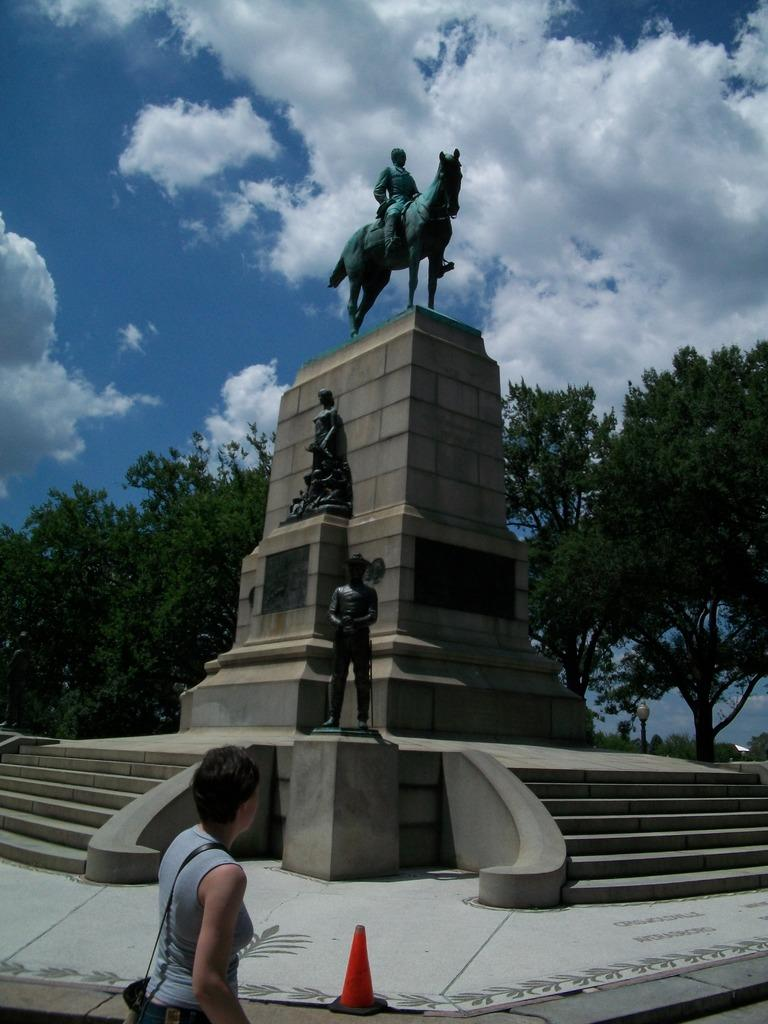What is the main subject in the image? There is a person standing in the image. What can be seen on the pillar in the image? There are sculptures on a pillar in the image. What architectural feature is visible in the image? There are stairs visible in the image. What type of vegetation is present in the image? There are trees with branches and leaves in the image. What is visible in the sky in the image? The sky is visible in the image, and there are clouds present. What is the value of the heat generated by the trees in the image? There is no heat generated by the trees in the image, as trees do not produce heat. 